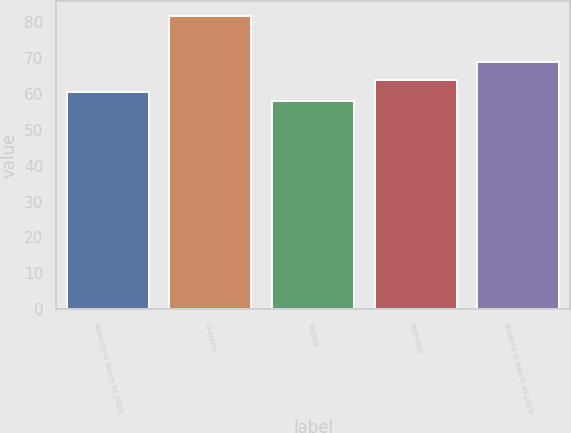<chart> <loc_0><loc_0><loc_500><loc_500><bar_chart><fcel>Balance at March 31 2018<fcel>Granted<fcel>Vested<fcel>Forfeited<fcel>Balance at March 30 2019<nl><fcel>60.45<fcel>81.83<fcel>58.08<fcel>64.01<fcel>69.03<nl></chart> 